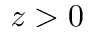<formula> <loc_0><loc_0><loc_500><loc_500>z > 0</formula> 